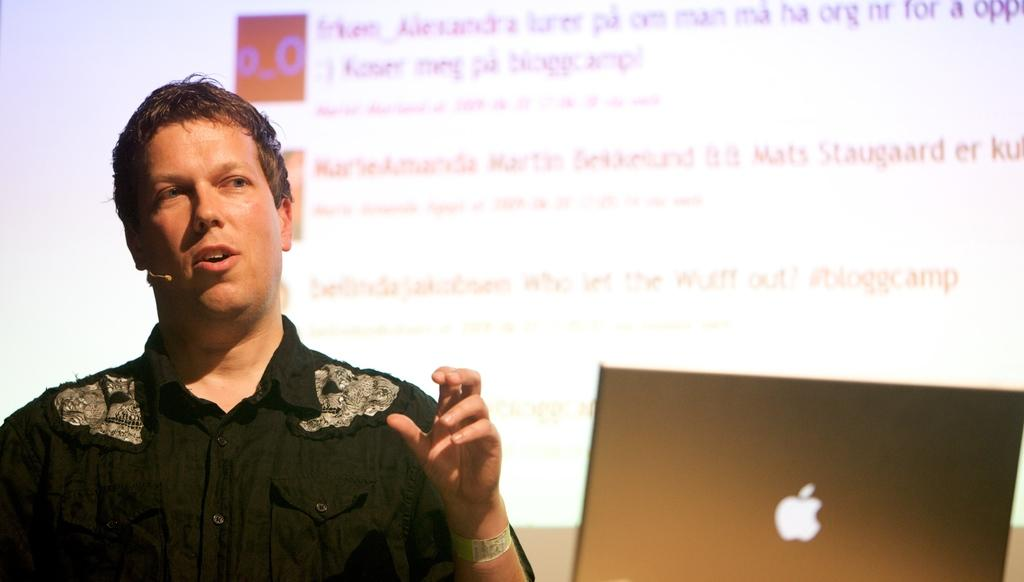Who is the main subject in the image? There is a man in the middle of the image. What is the man doing in the image? The man is holding a mic to his ear. What object is in front of the man? There is a laptop in front of the man. What can be seen in the background of the image? There is a screen in the background of the image. What information is displayed on the screen? There is text visible on the screen. How many units of insects can be seen playing on the laptop in the image? There are no insects or units visible on the laptop in the image. 